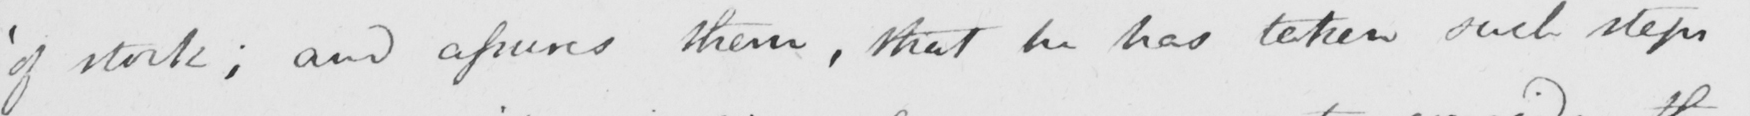Transcribe the text shown in this historical manuscript line. of  ' stock ; and assures them that he has taken such steps 